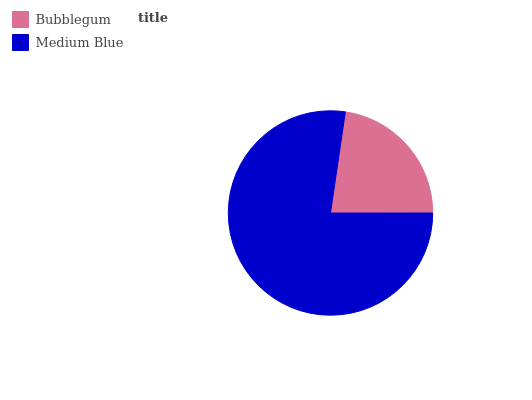Is Bubblegum the minimum?
Answer yes or no. Yes. Is Medium Blue the maximum?
Answer yes or no. Yes. Is Medium Blue the minimum?
Answer yes or no. No. Is Medium Blue greater than Bubblegum?
Answer yes or no. Yes. Is Bubblegum less than Medium Blue?
Answer yes or no. Yes. Is Bubblegum greater than Medium Blue?
Answer yes or no. No. Is Medium Blue less than Bubblegum?
Answer yes or no. No. Is Medium Blue the high median?
Answer yes or no. Yes. Is Bubblegum the low median?
Answer yes or no. Yes. Is Bubblegum the high median?
Answer yes or no. No. Is Medium Blue the low median?
Answer yes or no. No. 